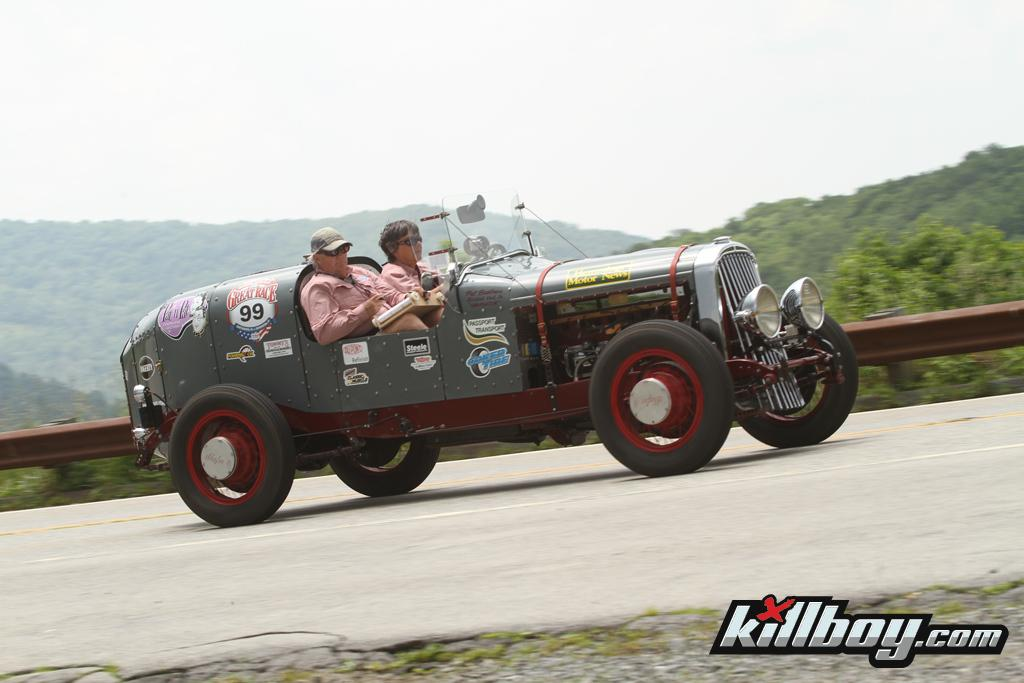How many people are inside the vehicle in the image? There are two persons inside the vehicle in the image. What is the setting of the image? The image depicts a road. What can be seen in the background of the image? There are trees and a mountain visible in the background. What is visible at the top of the image? The sky is visible in the image. Can you see any pigs running across the road in the image? There are no pigs visible in the image, and no running animals are depicted. 